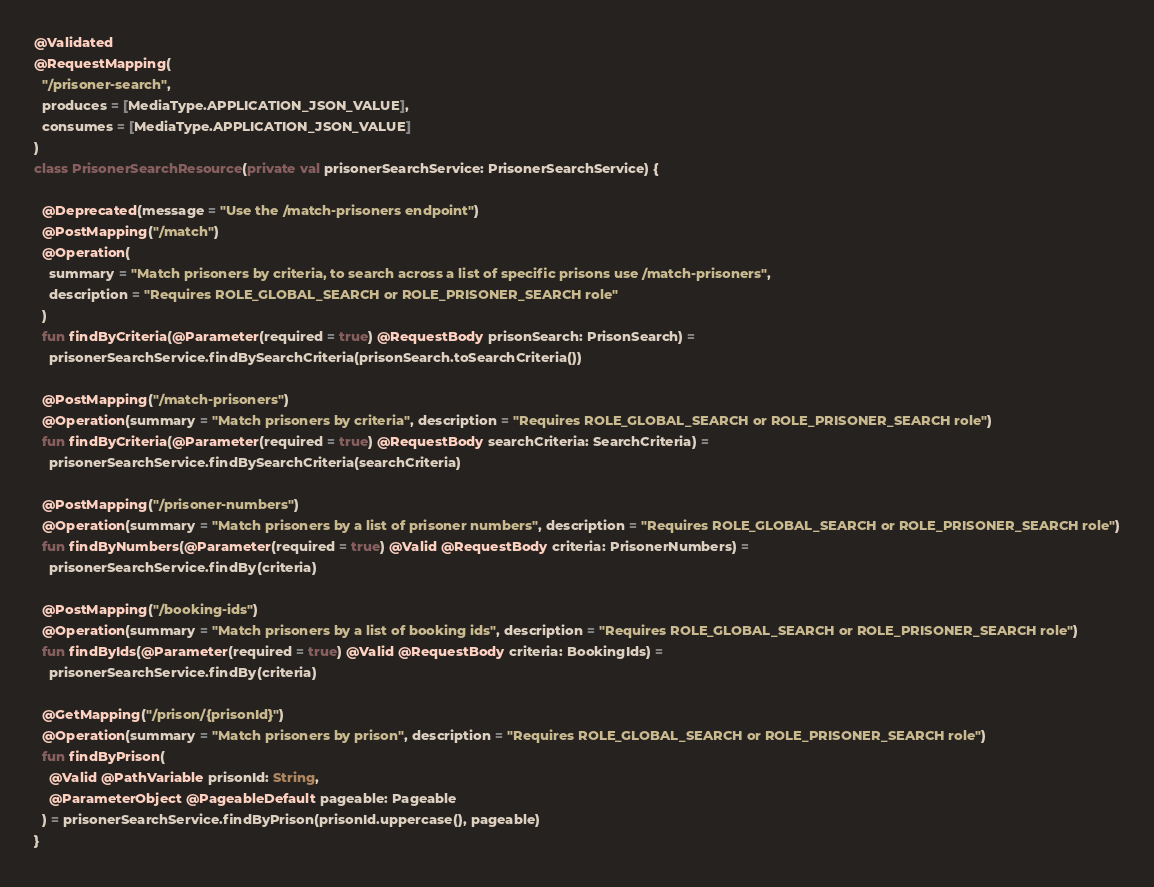<code> <loc_0><loc_0><loc_500><loc_500><_Kotlin_>@Validated
@RequestMapping(
  "/prisoner-search",
  produces = [MediaType.APPLICATION_JSON_VALUE],
  consumes = [MediaType.APPLICATION_JSON_VALUE]
)
class PrisonerSearchResource(private val prisonerSearchService: PrisonerSearchService) {

  @Deprecated(message = "Use the /match-prisoners endpoint")
  @PostMapping("/match")
  @Operation(
    summary = "Match prisoners by criteria, to search across a list of specific prisons use /match-prisoners",
    description = "Requires ROLE_GLOBAL_SEARCH or ROLE_PRISONER_SEARCH role"
  )
  fun findByCriteria(@Parameter(required = true) @RequestBody prisonSearch: PrisonSearch) =
    prisonerSearchService.findBySearchCriteria(prisonSearch.toSearchCriteria())

  @PostMapping("/match-prisoners")
  @Operation(summary = "Match prisoners by criteria", description = "Requires ROLE_GLOBAL_SEARCH or ROLE_PRISONER_SEARCH role")
  fun findByCriteria(@Parameter(required = true) @RequestBody searchCriteria: SearchCriteria) =
    prisonerSearchService.findBySearchCriteria(searchCriteria)

  @PostMapping("/prisoner-numbers")
  @Operation(summary = "Match prisoners by a list of prisoner numbers", description = "Requires ROLE_GLOBAL_SEARCH or ROLE_PRISONER_SEARCH role")
  fun findByNumbers(@Parameter(required = true) @Valid @RequestBody criteria: PrisonerNumbers) =
    prisonerSearchService.findBy(criteria)

  @PostMapping("/booking-ids")
  @Operation(summary = "Match prisoners by a list of booking ids", description = "Requires ROLE_GLOBAL_SEARCH or ROLE_PRISONER_SEARCH role")
  fun findByIds(@Parameter(required = true) @Valid @RequestBody criteria: BookingIds) =
    prisonerSearchService.findBy(criteria)

  @GetMapping("/prison/{prisonId}")
  @Operation(summary = "Match prisoners by prison", description = "Requires ROLE_GLOBAL_SEARCH or ROLE_PRISONER_SEARCH role")
  fun findByPrison(
    @Valid @PathVariable prisonId: String,
    @ParameterObject @PageableDefault pageable: Pageable
  ) = prisonerSearchService.findByPrison(prisonId.uppercase(), pageable)
}
</code> 